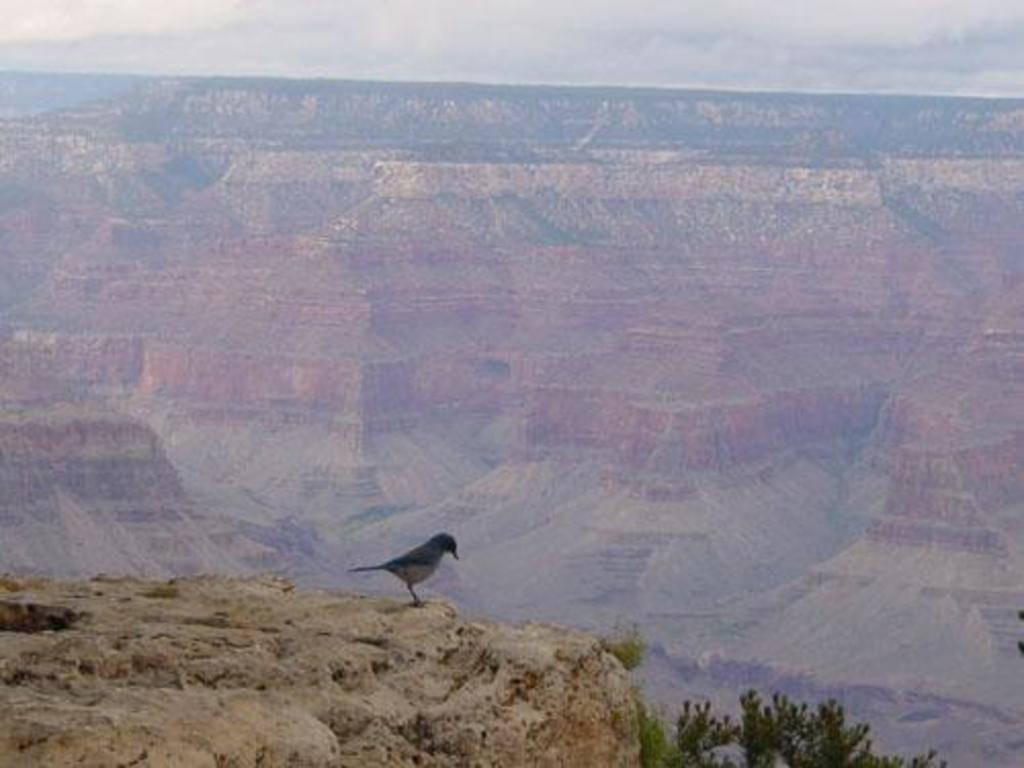What type of animal can be seen in the image? There is a bird in the bottom of the picture. What can be seen in the distance in the image? Hills are visible in the background of the image. What is present in the sky in the background of the image? Clouds are present in the sky in the background of the image. What type of frame surrounds the bird in the image? There is no frame present in the image; it is a photograph or digital image without a frame. 